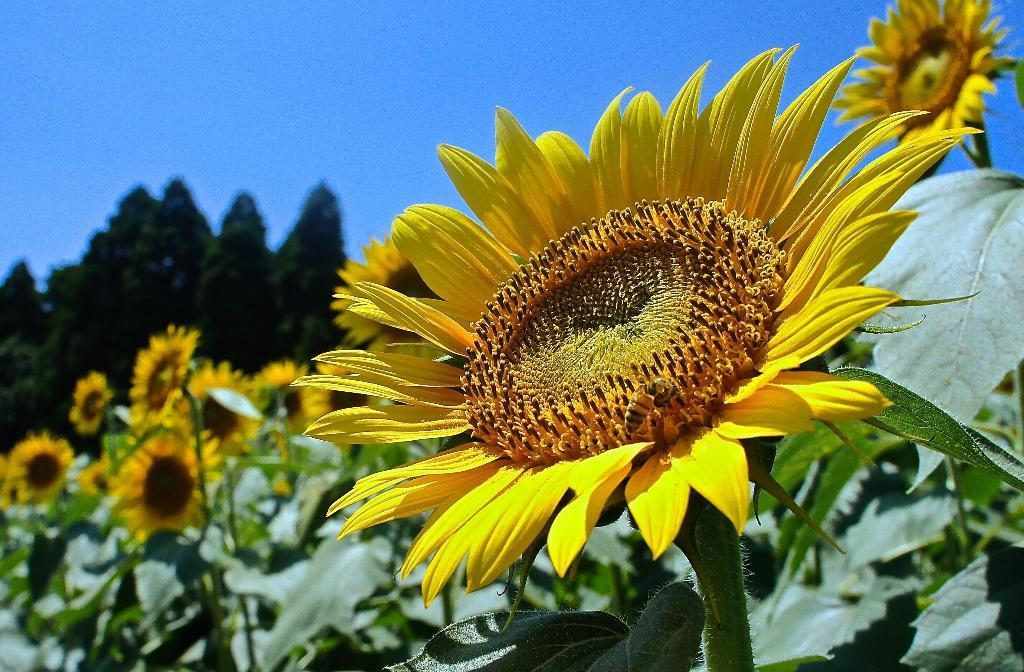What type of plants are present in the image? The image contains plants with flowers. What color are the flowers on the plants? The flowers are yellow in color. What other natural elements can be seen in the image? There are trees visible in the image. What is the color of the sky in the image? The sky is blue in the image. What type of shirt is hanging on the tree in the image? There is no shirt present in the image; it features plants with yellow flowers, trees, and a blue sky. 